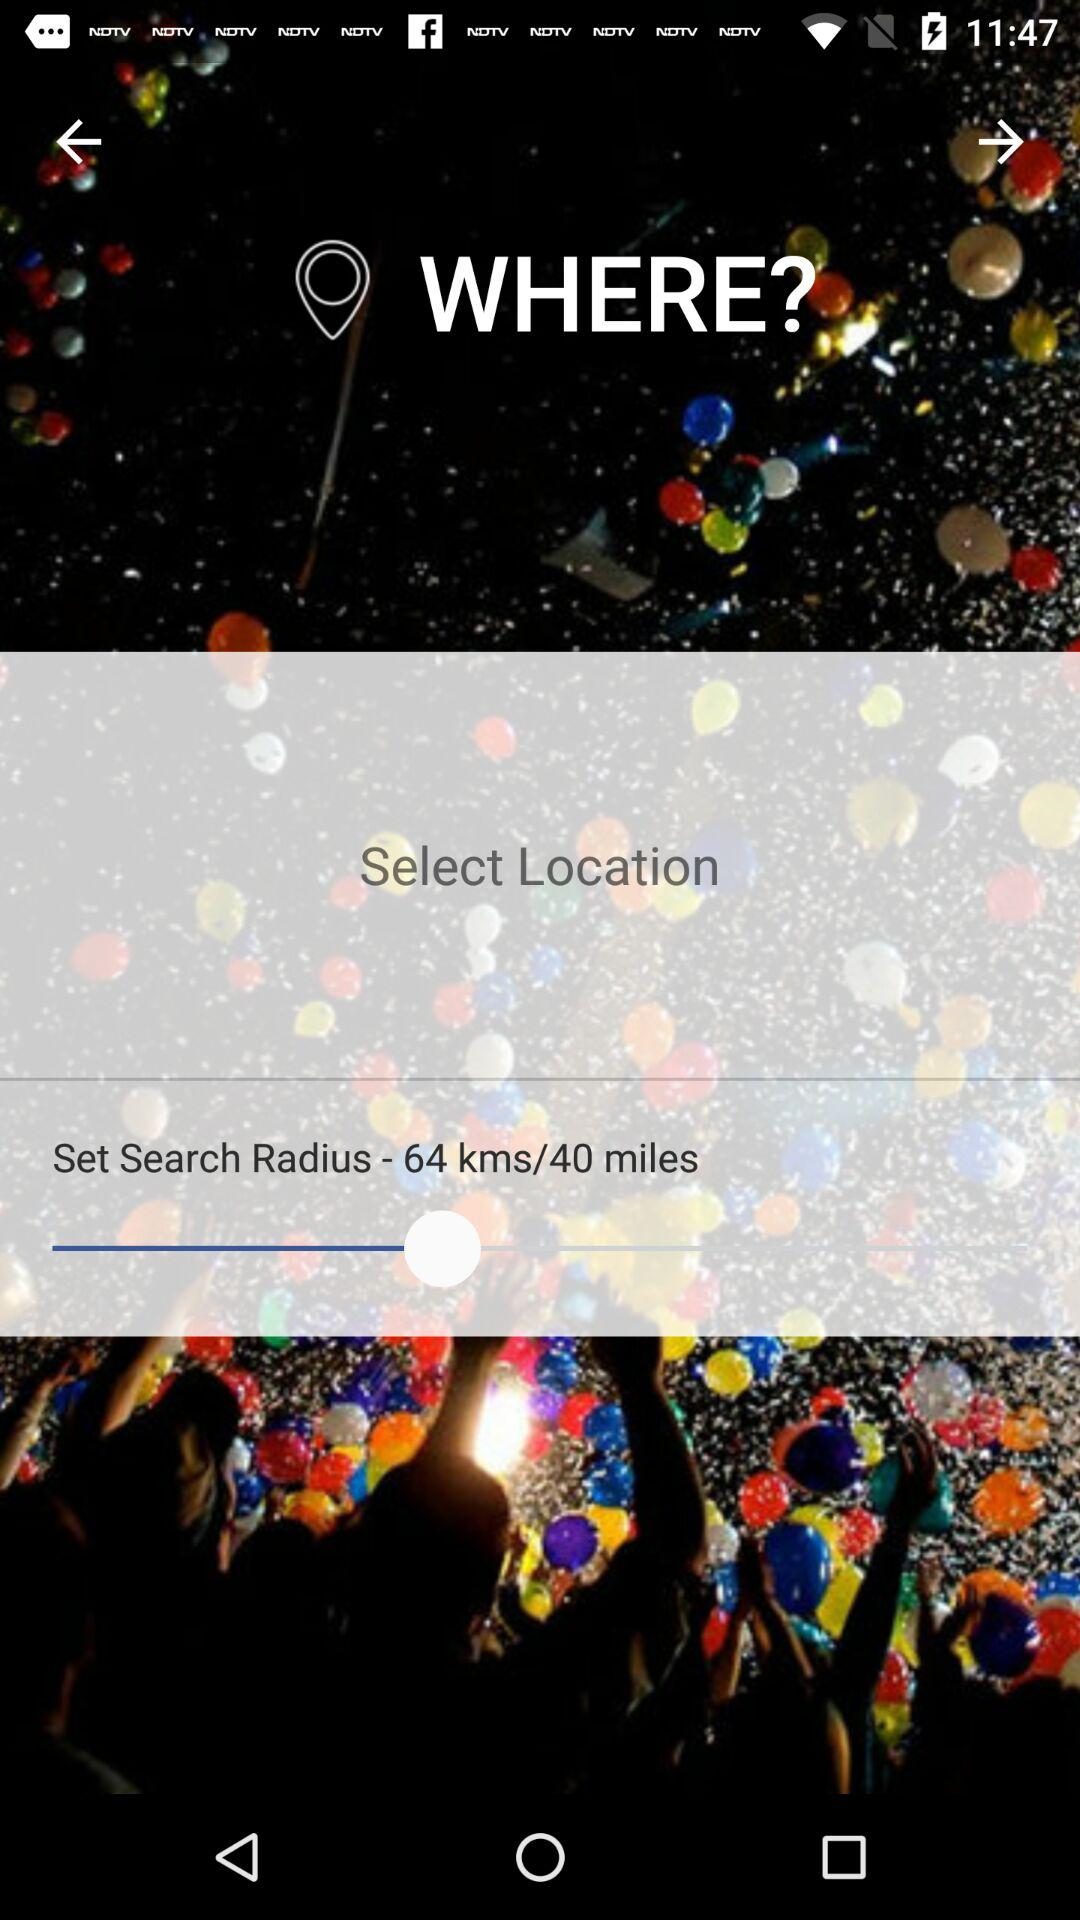How many more kms than miles is the search radius set to?
Answer the question using a single word or phrase. 24 